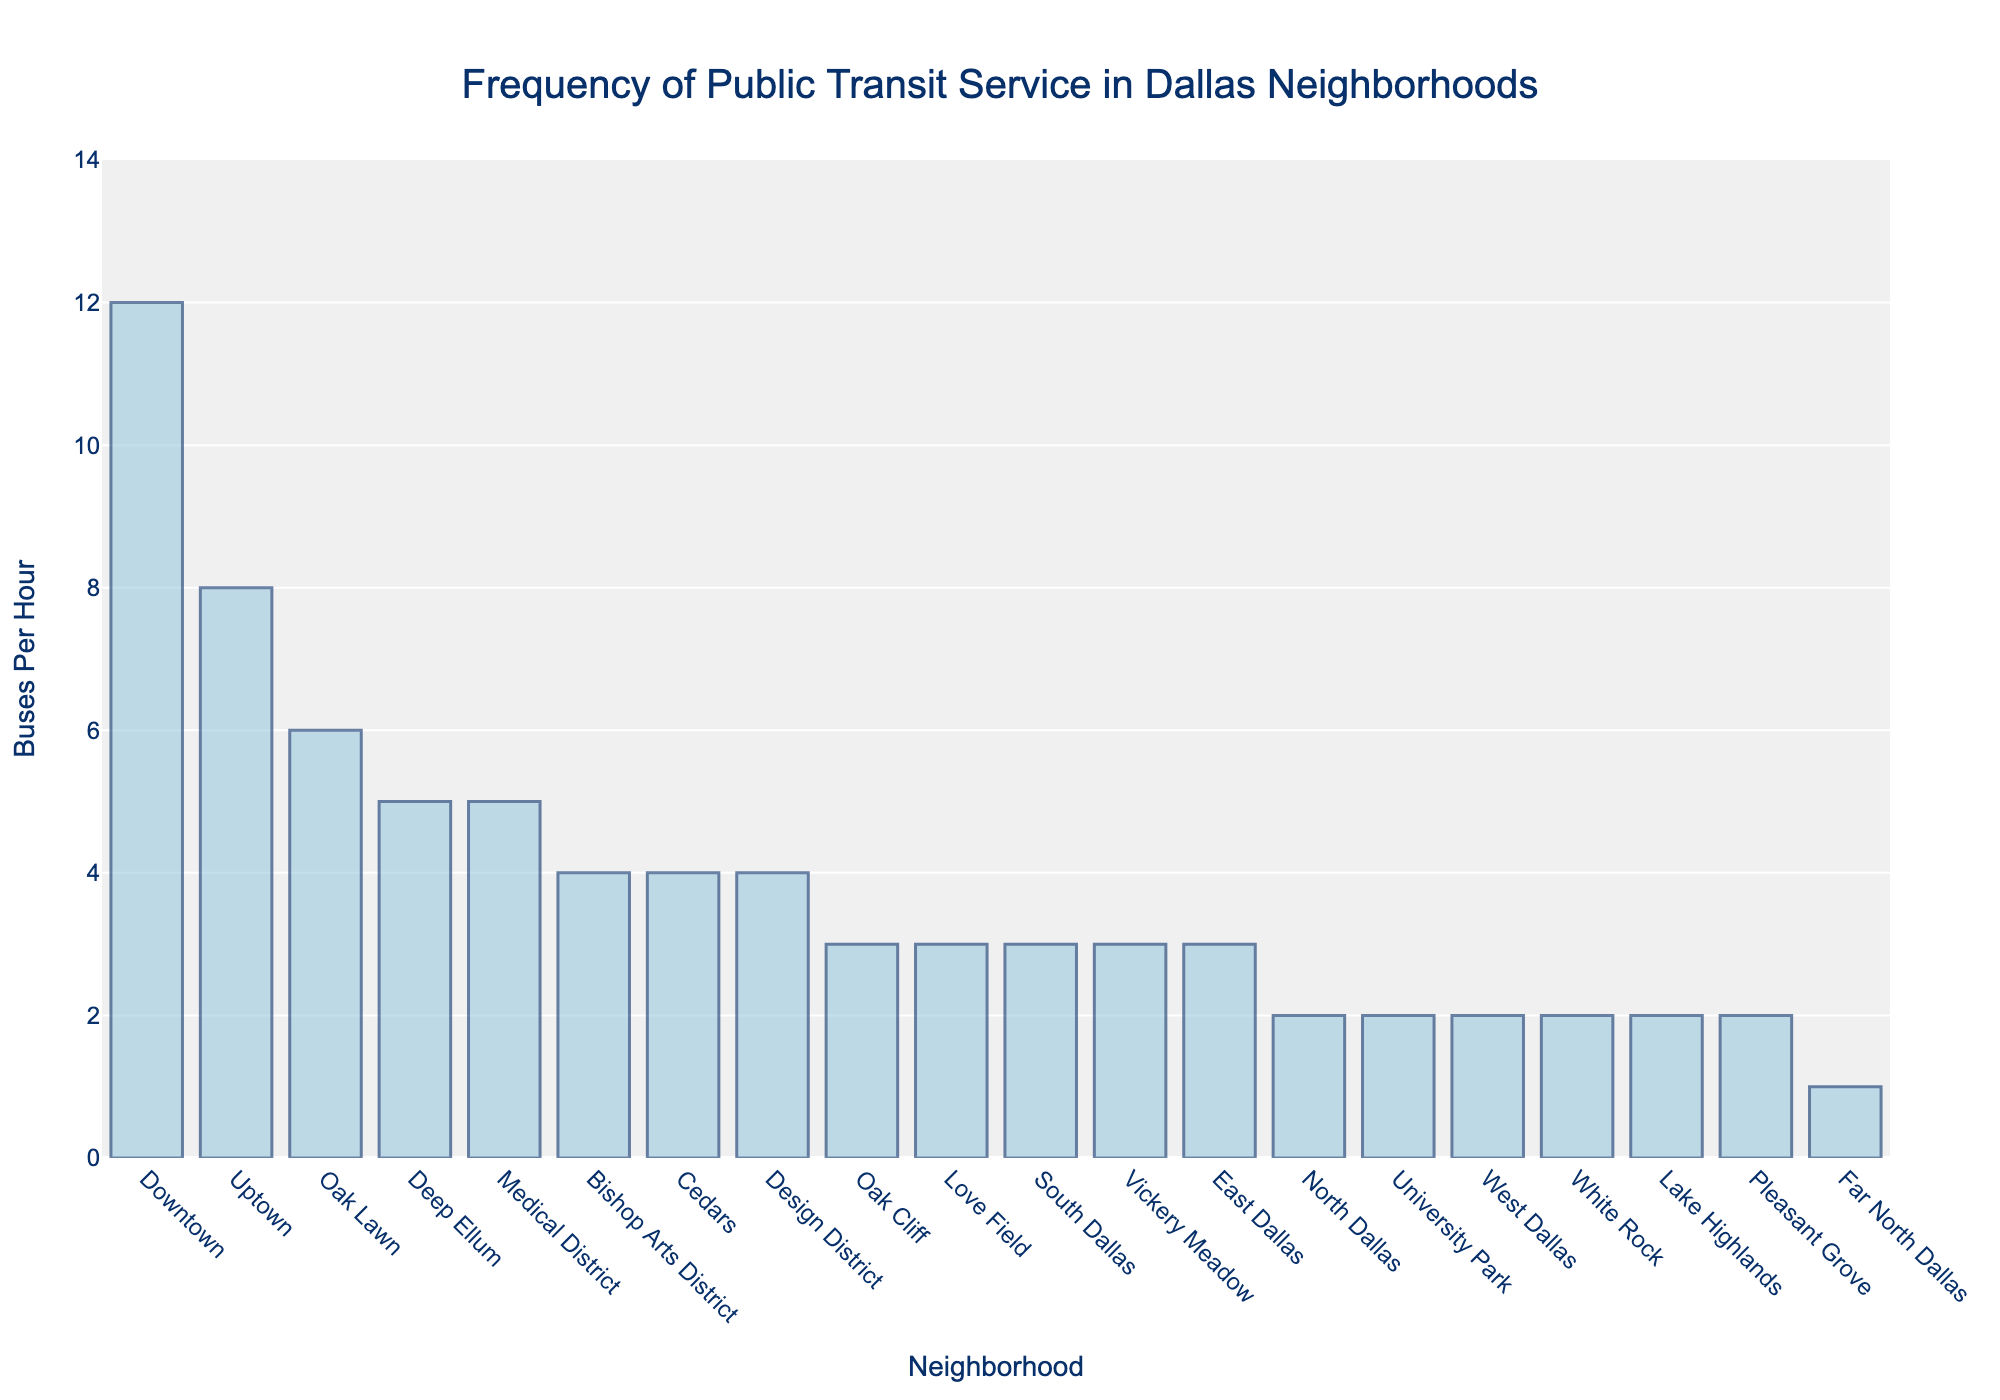Which neighborhood has the highest frequency of buses per hour? By looking at the height of the bars, the bar representing Downtown is the tallest, indicating the highest frequency of buses per hour among the neighborhoods. Therefore, Downtown has the highest frequency of buses per hour.
Answer: Downtown Which two neighborhoods have the same number of buses per hour? By checking the lengths of the bars, we see that Bishop Arts District, Cedars, and Design District all have bars of the same height, indicating they have the same number of buses per hour. Additionally, Pleasant Grove, Lake Highlands, White Rock, West Dallas, and North Dallas also share the same number.
Answer: Bishop Arts District, Cedars, Design District; Pleasant Grove, Lake Highlands, White Rock, West Dallas, North Dallas How many buses per hour are there in South Dallas, and is this greater than the buses per hour in Oak Cliff? The bar for South Dallas reaches 3 on the y-axis, and Oak Cliff also has a bar reaching 3 on the y-axis. Therefore, South Dallas has 3 buses per hour and it is equal to the buses per hour in Oak Cliff.
Answer: 3, equal What's the average number of buses per hour for the neighborhoods with the top 3 highest frequencies? The neighborhoods with the top 3 frequencies are Downtown (12), Uptown (8), and Oak Lawn (6). Summing these up gives 12 + 8 + 6 = 26, and the average is found by dividing this sum by 3, resulting in 26 / 3 ≈ 8.67.
Answer: 8.67 Which neighborhood has fewer buses per hour, Deep Ellum or Medical District? The bar for Deep Ellum reaches 5 on the y-axis, and the bar for Medical District also reaches 5 on the y-axis, indicating both have the same number of buses per hour, which is 5.
Answer: Same (5) What is the total number of buses per hour if combining all neighborhoods with 2 buses per hour? The neighborhoods with 2 buses per hour are Pleasant Grove, Lake Highlands, White Rock, West Dallas, and North Dallas. Summing these up gives 2 + 2 + 2 + 2 + 2 = 10.
Answer: 10 Which neighborhood has the lowest frequency of buses per hour, and what is that frequency? By observing the bar chart, Far North Dallas has the shortest bar, indicating the lowest frequency, which is 1 bus per hour.
Answer: Far North Dallas, 1 What is the difference in buses per hour between Downtown and Uptown? The bar for Downtown reaches 12 on the y-axis and the bar for Uptown reaches 8 on the y-axis. The difference is calculated by subtracting 8 from 12, resulting in 12 - 8 = 4.
Answer: 4 